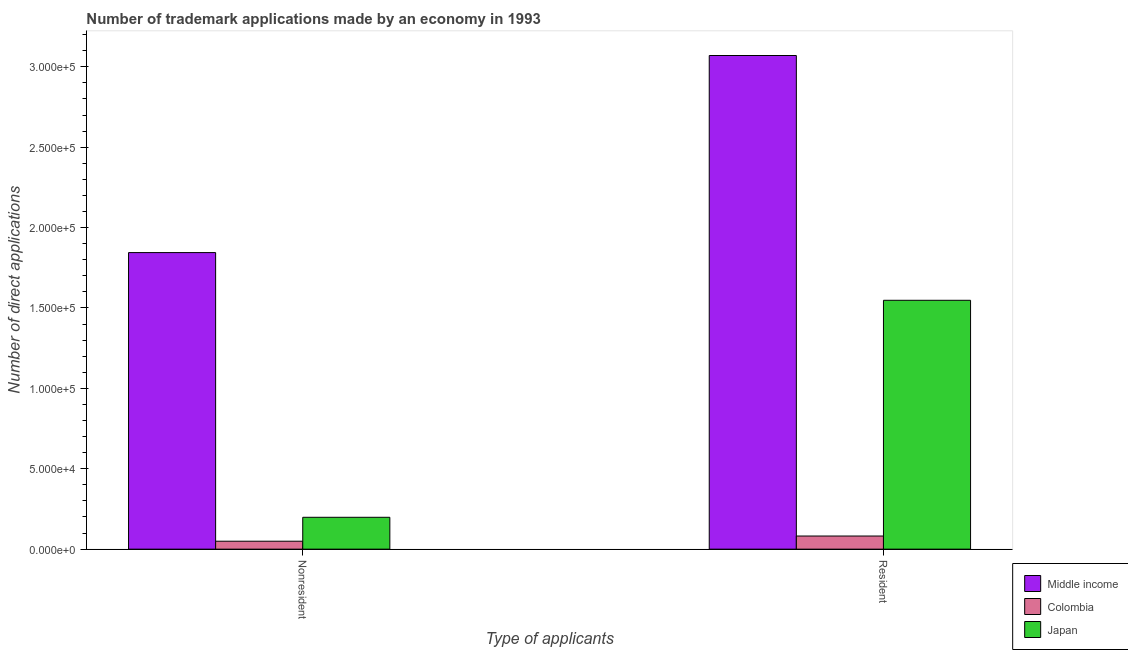How many different coloured bars are there?
Your answer should be compact. 3. Are the number of bars on each tick of the X-axis equal?
Your response must be concise. Yes. How many bars are there on the 2nd tick from the left?
Keep it short and to the point. 3. What is the label of the 2nd group of bars from the left?
Provide a short and direct response. Resident. What is the number of trademark applications made by residents in Colombia?
Your answer should be very brief. 8167. Across all countries, what is the maximum number of trademark applications made by non residents?
Make the answer very short. 1.84e+05. Across all countries, what is the minimum number of trademark applications made by residents?
Your response must be concise. 8167. In which country was the number of trademark applications made by non residents maximum?
Your answer should be compact. Middle income. In which country was the number of trademark applications made by residents minimum?
Your response must be concise. Colombia. What is the total number of trademark applications made by residents in the graph?
Give a very brief answer. 4.70e+05. What is the difference between the number of trademark applications made by residents in Colombia and that in Middle income?
Your answer should be compact. -2.99e+05. What is the difference between the number of trademark applications made by non residents in Colombia and the number of trademark applications made by residents in Japan?
Your answer should be very brief. -1.50e+05. What is the average number of trademark applications made by residents per country?
Make the answer very short. 1.57e+05. What is the difference between the number of trademark applications made by non residents and number of trademark applications made by residents in Colombia?
Provide a short and direct response. -3234. What is the ratio of the number of trademark applications made by non residents in Colombia to that in Middle income?
Make the answer very short. 0.03. In how many countries, is the number of trademark applications made by residents greater than the average number of trademark applications made by residents taken over all countries?
Offer a very short reply. 1. What does the 2nd bar from the right in Resident represents?
Make the answer very short. Colombia. How many bars are there?
Give a very brief answer. 6. Are all the bars in the graph horizontal?
Provide a short and direct response. No. How many countries are there in the graph?
Offer a terse response. 3. Are the values on the major ticks of Y-axis written in scientific E-notation?
Offer a terse response. Yes. Does the graph contain grids?
Offer a very short reply. No. Where does the legend appear in the graph?
Your answer should be compact. Bottom right. How many legend labels are there?
Provide a short and direct response. 3. How are the legend labels stacked?
Ensure brevity in your answer.  Vertical. What is the title of the graph?
Your response must be concise. Number of trademark applications made by an economy in 1993. What is the label or title of the X-axis?
Ensure brevity in your answer.  Type of applicants. What is the label or title of the Y-axis?
Make the answer very short. Number of direct applications. What is the Number of direct applications of Middle income in Nonresident?
Provide a succinct answer. 1.84e+05. What is the Number of direct applications of Colombia in Nonresident?
Keep it short and to the point. 4933. What is the Number of direct applications of Japan in Nonresident?
Keep it short and to the point. 1.98e+04. What is the Number of direct applications in Middle income in Resident?
Provide a short and direct response. 3.07e+05. What is the Number of direct applications of Colombia in Resident?
Offer a terse response. 8167. What is the Number of direct applications of Japan in Resident?
Give a very brief answer. 1.55e+05. Across all Type of applicants, what is the maximum Number of direct applications in Middle income?
Offer a terse response. 3.07e+05. Across all Type of applicants, what is the maximum Number of direct applications of Colombia?
Offer a terse response. 8167. Across all Type of applicants, what is the maximum Number of direct applications in Japan?
Keep it short and to the point. 1.55e+05. Across all Type of applicants, what is the minimum Number of direct applications in Middle income?
Your answer should be very brief. 1.84e+05. Across all Type of applicants, what is the minimum Number of direct applications in Colombia?
Offer a terse response. 4933. Across all Type of applicants, what is the minimum Number of direct applications in Japan?
Keep it short and to the point. 1.98e+04. What is the total Number of direct applications in Middle income in the graph?
Your response must be concise. 4.91e+05. What is the total Number of direct applications in Colombia in the graph?
Your answer should be very brief. 1.31e+04. What is the total Number of direct applications of Japan in the graph?
Make the answer very short. 1.75e+05. What is the difference between the Number of direct applications of Middle income in Nonresident and that in Resident?
Provide a short and direct response. -1.23e+05. What is the difference between the Number of direct applications in Colombia in Nonresident and that in Resident?
Your response must be concise. -3234. What is the difference between the Number of direct applications of Japan in Nonresident and that in Resident?
Provide a succinct answer. -1.35e+05. What is the difference between the Number of direct applications of Middle income in Nonresident and the Number of direct applications of Colombia in Resident?
Keep it short and to the point. 1.76e+05. What is the difference between the Number of direct applications of Middle income in Nonresident and the Number of direct applications of Japan in Resident?
Offer a terse response. 2.97e+04. What is the difference between the Number of direct applications in Colombia in Nonresident and the Number of direct applications in Japan in Resident?
Your answer should be very brief. -1.50e+05. What is the average Number of direct applications of Middle income per Type of applicants?
Offer a very short reply. 2.46e+05. What is the average Number of direct applications of Colombia per Type of applicants?
Give a very brief answer. 6550. What is the average Number of direct applications in Japan per Type of applicants?
Provide a succinct answer. 8.73e+04. What is the difference between the Number of direct applications of Middle income and Number of direct applications of Colombia in Nonresident?
Make the answer very short. 1.80e+05. What is the difference between the Number of direct applications in Middle income and Number of direct applications in Japan in Nonresident?
Your answer should be very brief. 1.65e+05. What is the difference between the Number of direct applications of Colombia and Number of direct applications of Japan in Nonresident?
Your response must be concise. -1.49e+04. What is the difference between the Number of direct applications of Middle income and Number of direct applications of Colombia in Resident?
Keep it short and to the point. 2.99e+05. What is the difference between the Number of direct applications of Middle income and Number of direct applications of Japan in Resident?
Ensure brevity in your answer.  1.52e+05. What is the difference between the Number of direct applications in Colombia and Number of direct applications in Japan in Resident?
Ensure brevity in your answer.  -1.47e+05. What is the ratio of the Number of direct applications in Middle income in Nonresident to that in Resident?
Offer a very short reply. 0.6. What is the ratio of the Number of direct applications of Colombia in Nonresident to that in Resident?
Ensure brevity in your answer.  0.6. What is the ratio of the Number of direct applications of Japan in Nonresident to that in Resident?
Ensure brevity in your answer.  0.13. What is the difference between the highest and the second highest Number of direct applications in Middle income?
Give a very brief answer. 1.23e+05. What is the difference between the highest and the second highest Number of direct applications in Colombia?
Make the answer very short. 3234. What is the difference between the highest and the second highest Number of direct applications in Japan?
Your answer should be compact. 1.35e+05. What is the difference between the highest and the lowest Number of direct applications in Middle income?
Provide a short and direct response. 1.23e+05. What is the difference between the highest and the lowest Number of direct applications of Colombia?
Provide a succinct answer. 3234. What is the difference between the highest and the lowest Number of direct applications of Japan?
Provide a succinct answer. 1.35e+05. 